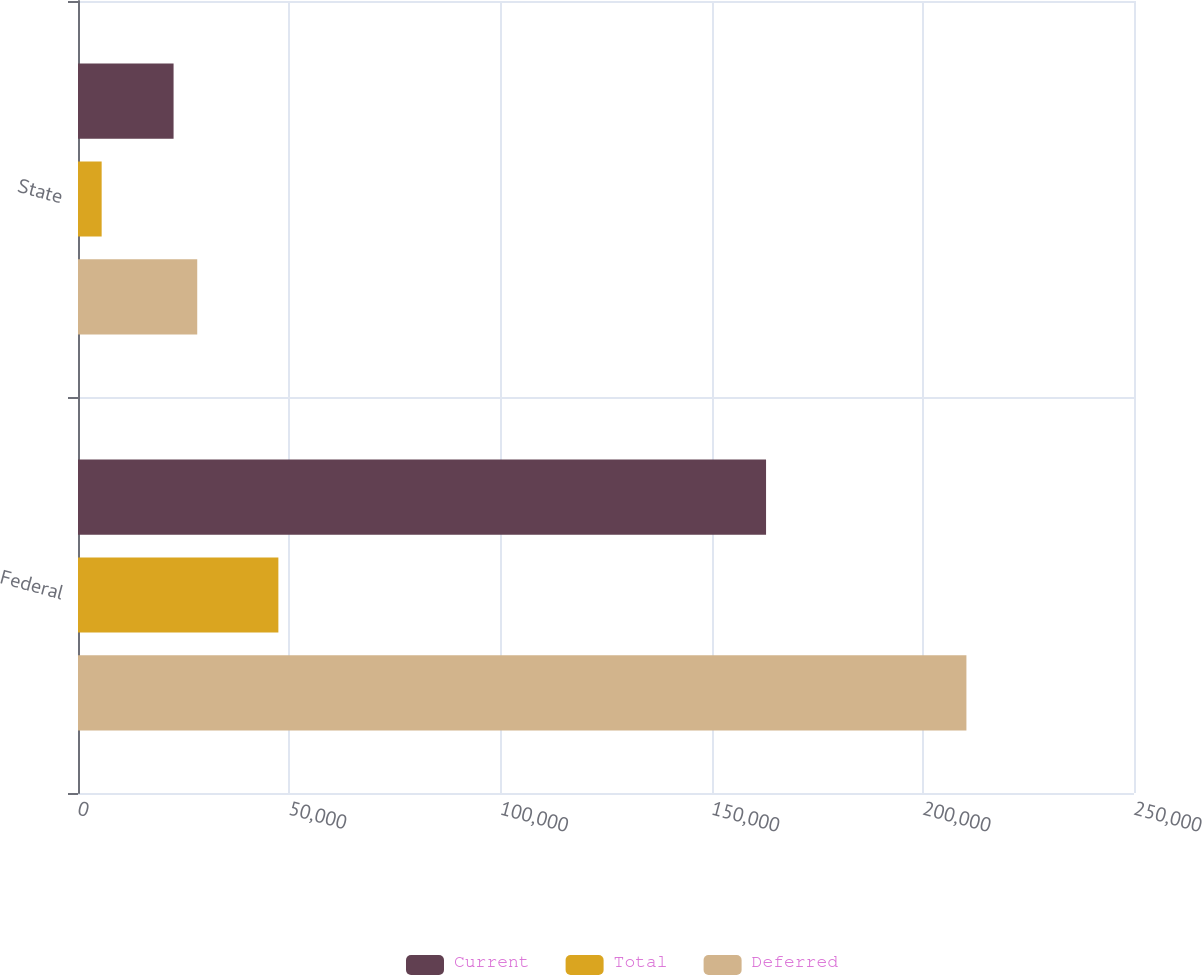Convert chart. <chart><loc_0><loc_0><loc_500><loc_500><stacked_bar_chart><ecel><fcel>Federal<fcel>State<nl><fcel>Current<fcel>162891<fcel>22626<nl><fcel>Total<fcel>47436<fcel>5601<nl><fcel>Deferred<fcel>210327<fcel>28227<nl></chart> 